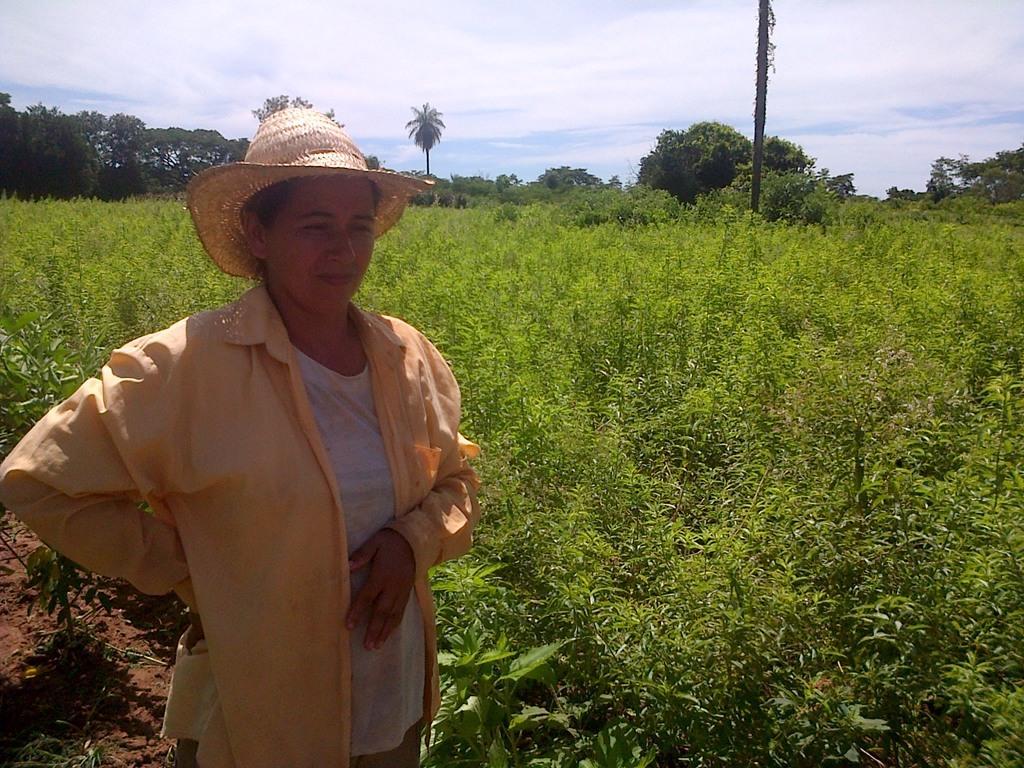In one or two sentences, can you explain what this image depicts? In this image we can see a woman wearing a hat standing on the ground. We can also see a group of plants, the bark of a tree, a group of trees and the sky which looks cloudy. 